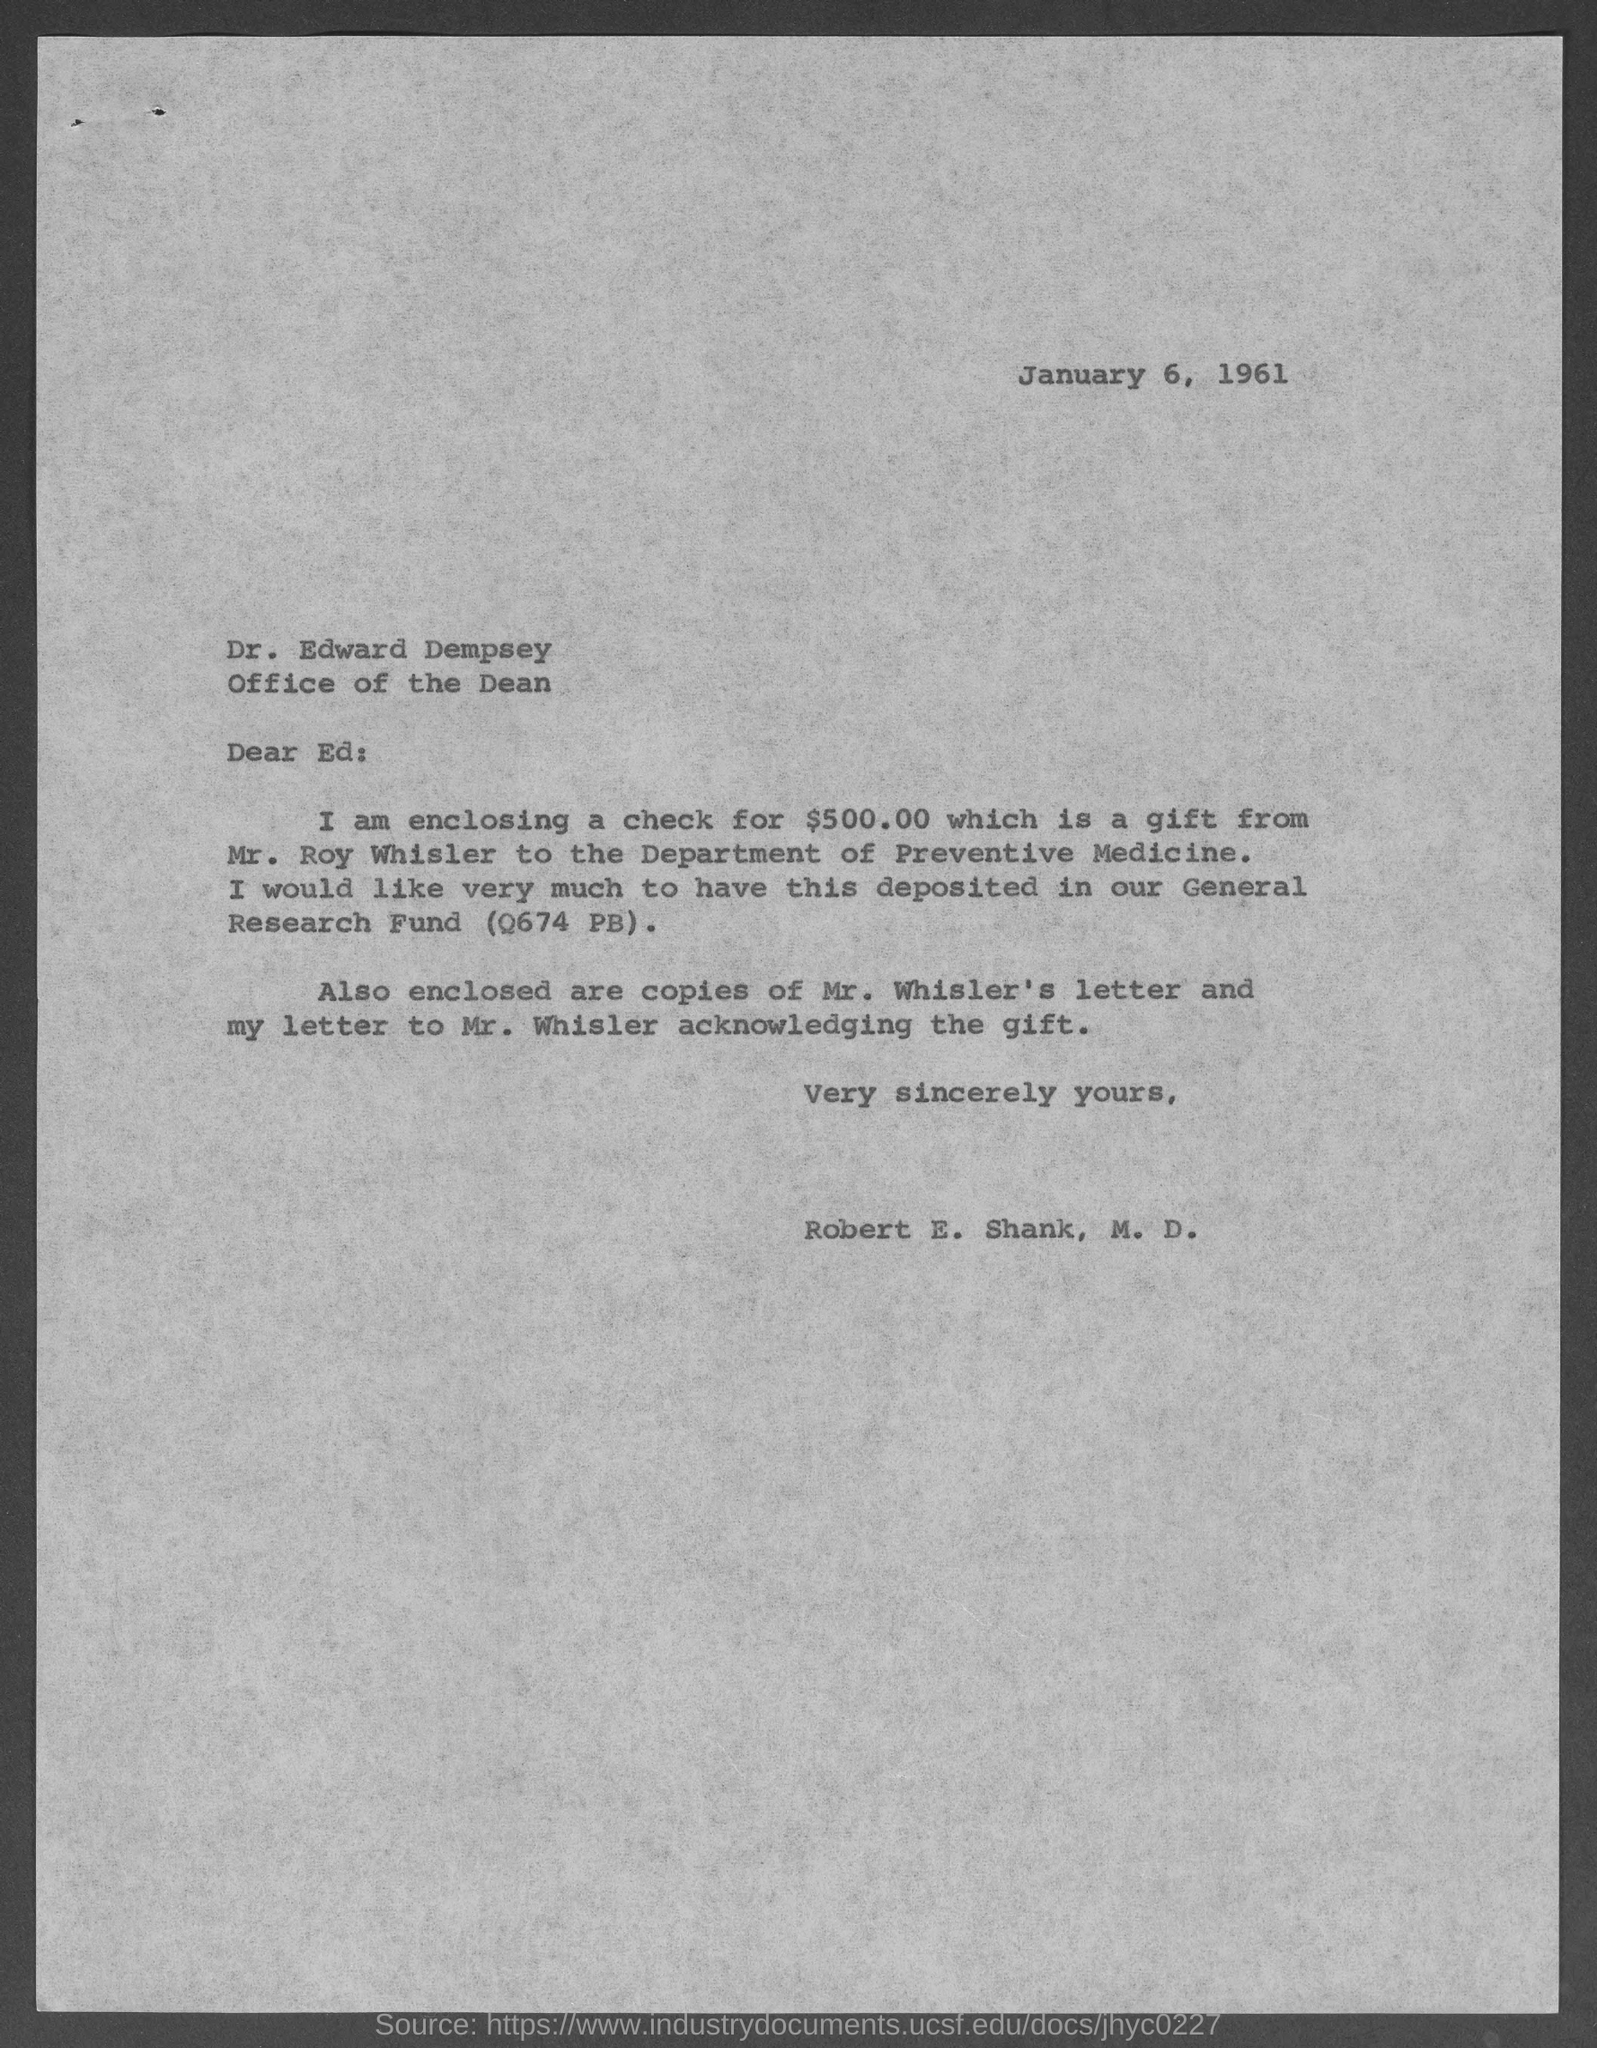What is the date mentioned ?
Make the answer very short. January 6, 1961. How much amount of check is enclosed ?
Give a very brief answer. $500.00. The enclosed check for $500 .00 is gift from whom ?
Offer a terse response. MR. ROY WHISLER. To whom the enclosed check for $500.00 is given
Provide a short and direct response. Department of preventive medicine. 